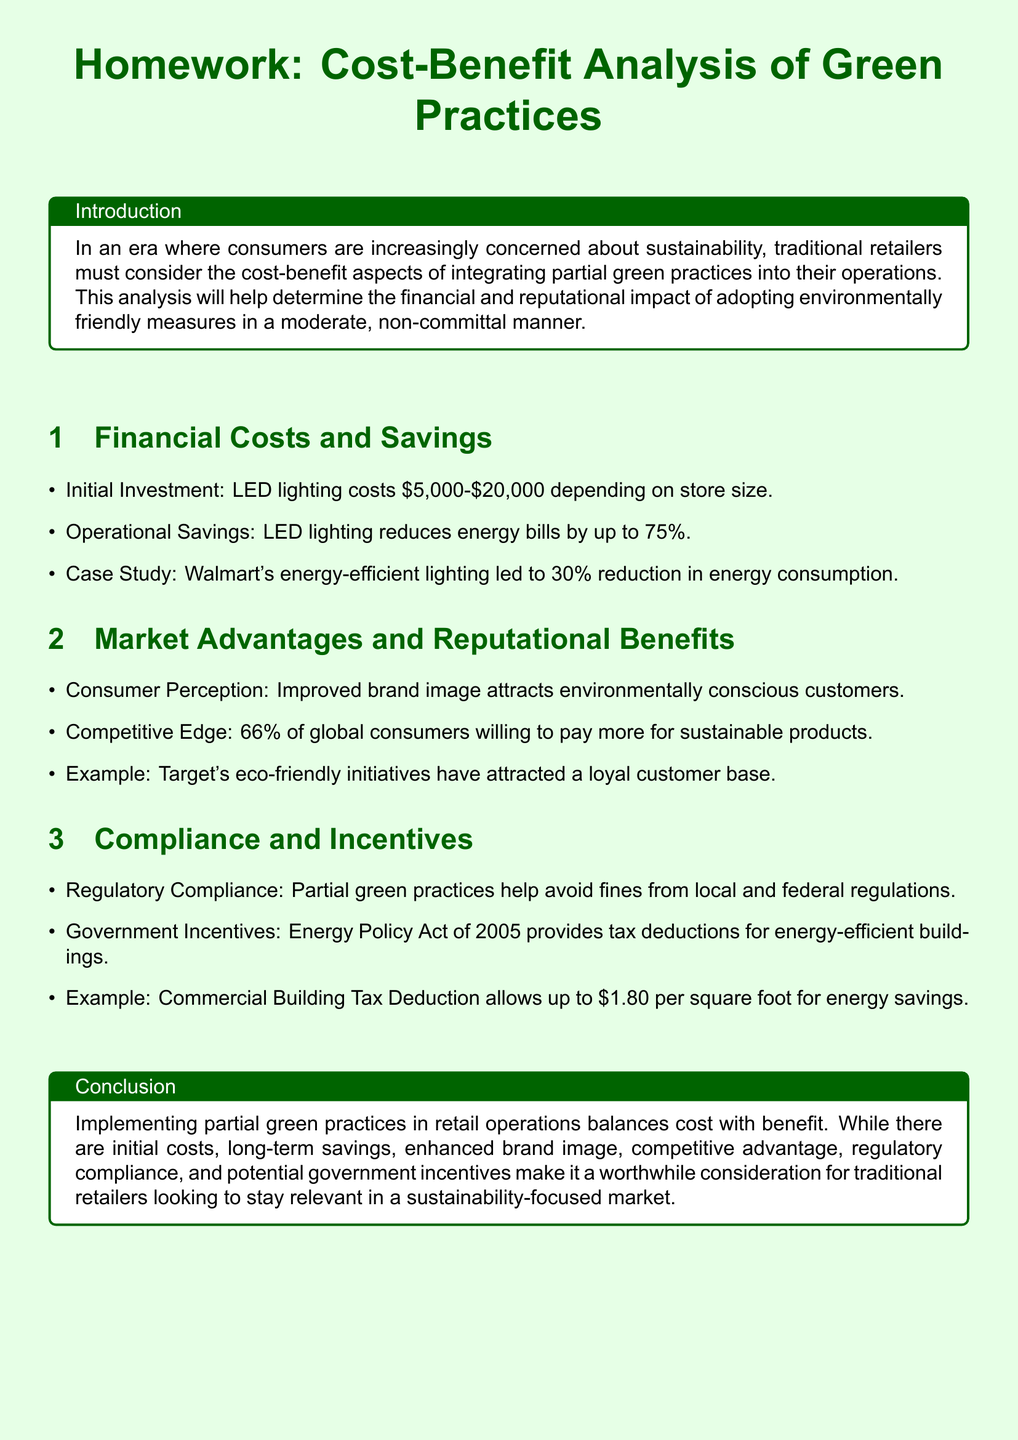What are the initial investment costs for LED lighting? The document states that LED lighting costs between \$5,000 and \$20,000 depending on store size.
Answer: \$5,000-\$20,000 What is the percentage of energy bill reduction from LED lighting? According to the document, LED lighting can reduce energy bills by up to 75%.
Answer: 75% Which retailer's eco-friendly initiatives have attracted a loyal customer base? The document mentions Target as an example of a retailer with successful eco-friendly initiatives.
Answer: Target What is the tax deduction allowed for energy savings under the Commercial Building Tax Deduction? The document specifies that the Commercial Building Tax Deduction allows up to \$1.80 per square foot for energy savings.
Answer: \$1.80 What is a key benefit of partial green practices mentioned in the document? The document highlights that partial green practices can help avoid fines from regulatory compliance.
Answer: Compliance How much percentage reduction in energy consumption did Walmart achieve through energy-efficient lighting? The document states that Walmart's energy-efficient lighting led to a 30% reduction in energy consumption.
Answer: 30% What percentage of global consumers are willing to pay more for sustainable products? The document indicates that 66% of global consumers are willing to pay more for sustainable products.
Answer: 66% What is the primary focus of the homework document? The document is focused on the cost-benefit analysis of implementing partial green practices in retail operations.
Answer: Cost-Benefit Analysis 